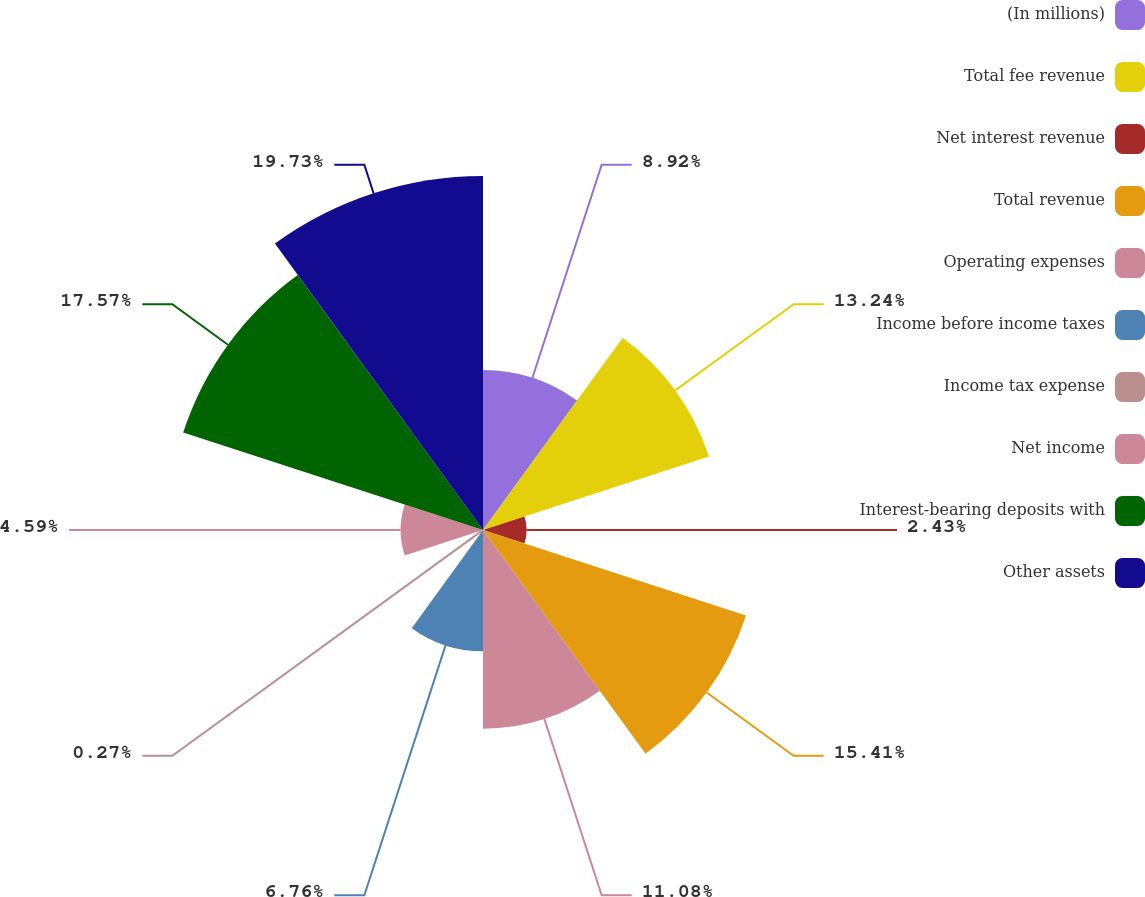<chart> <loc_0><loc_0><loc_500><loc_500><pie_chart><fcel>(In millions)<fcel>Total fee revenue<fcel>Net interest revenue<fcel>Total revenue<fcel>Operating expenses<fcel>Income before income taxes<fcel>Income tax expense<fcel>Net income<fcel>Interest-bearing deposits with<fcel>Other assets<nl><fcel>8.92%<fcel>13.24%<fcel>2.43%<fcel>15.41%<fcel>11.08%<fcel>6.76%<fcel>0.27%<fcel>4.59%<fcel>17.57%<fcel>19.73%<nl></chart> 